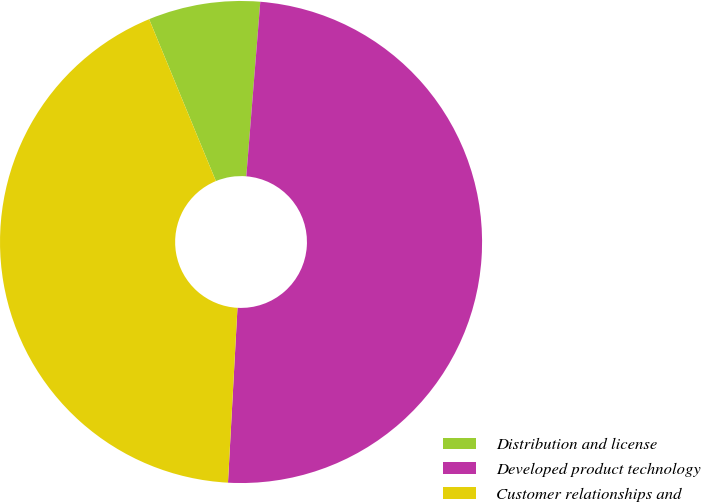<chart> <loc_0><loc_0><loc_500><loc_500><pie_chart><fcel>Distribution and license<fcel>Developed product technology<fcel>Customer relationships and<nl><fcel>7.5%<fcel>49.59%<fcel>42.91%<nl></chart> 